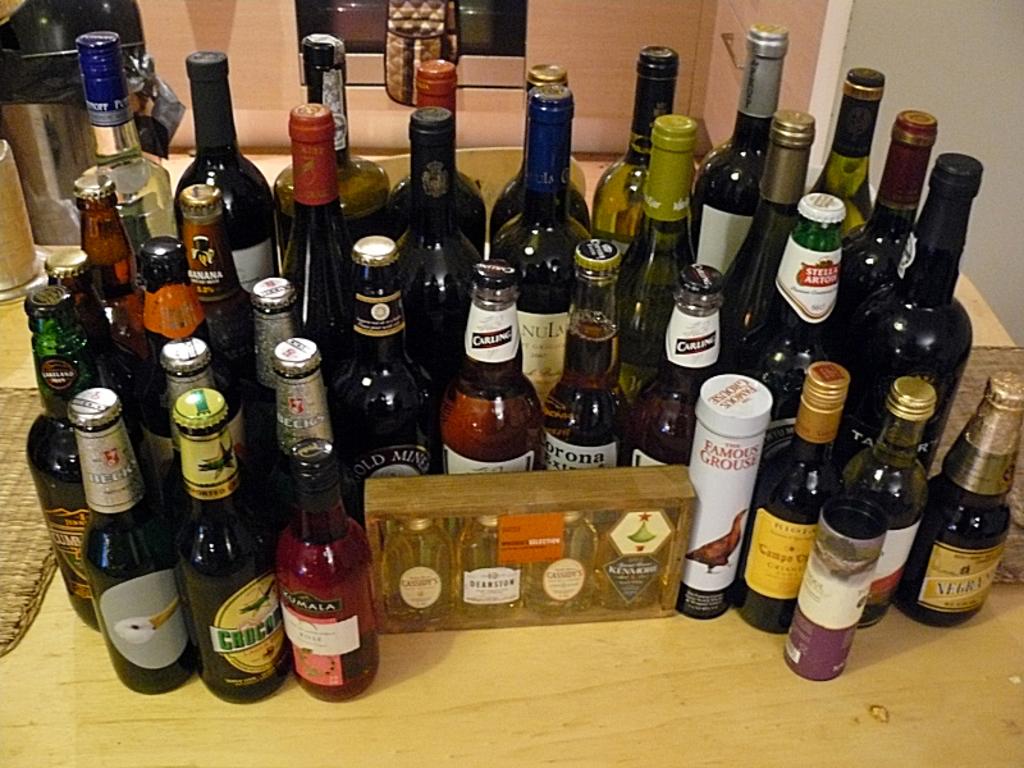What beer is featured on this bar?
Ensure brevity in your answer.  Unanswerable. What brand of beer has the bright red emblem on a green bottle?
Provide a short and direct response. Stella artois. 